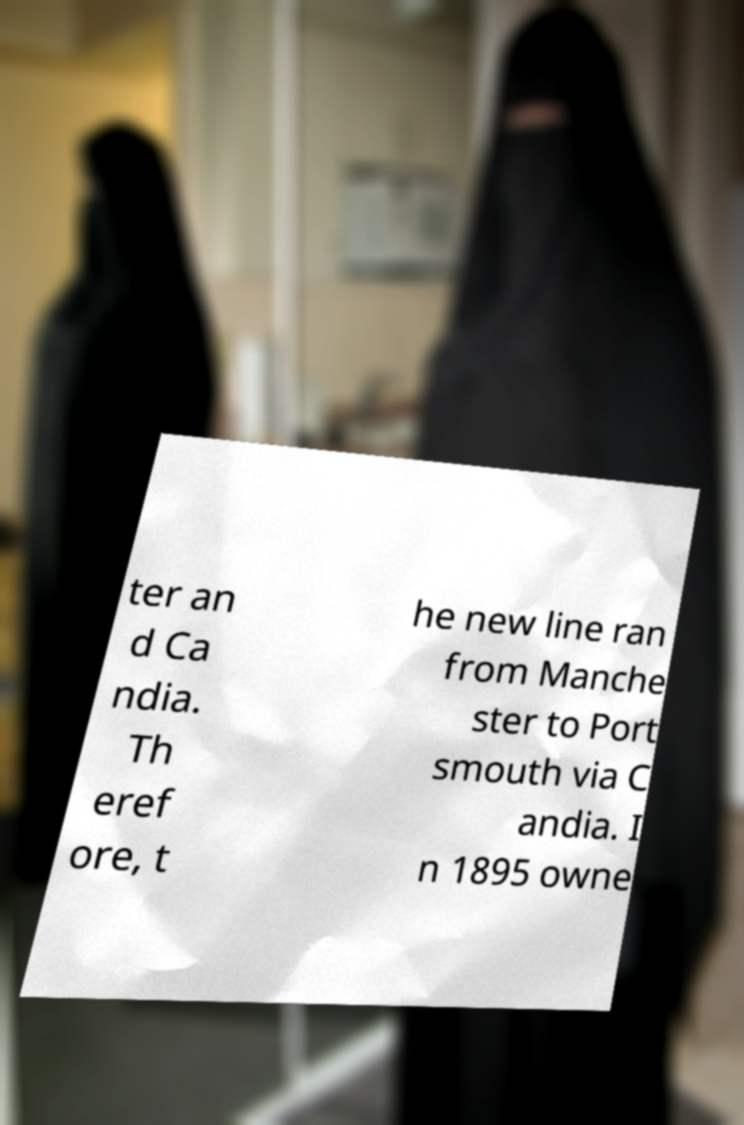Could you assist in decoding the text presented in this image and type it out clearly? ter an d Ca ndia. Th eref ore, t he new line ran from Manche ster to Port smouth via C andia. I n 1895 owne 